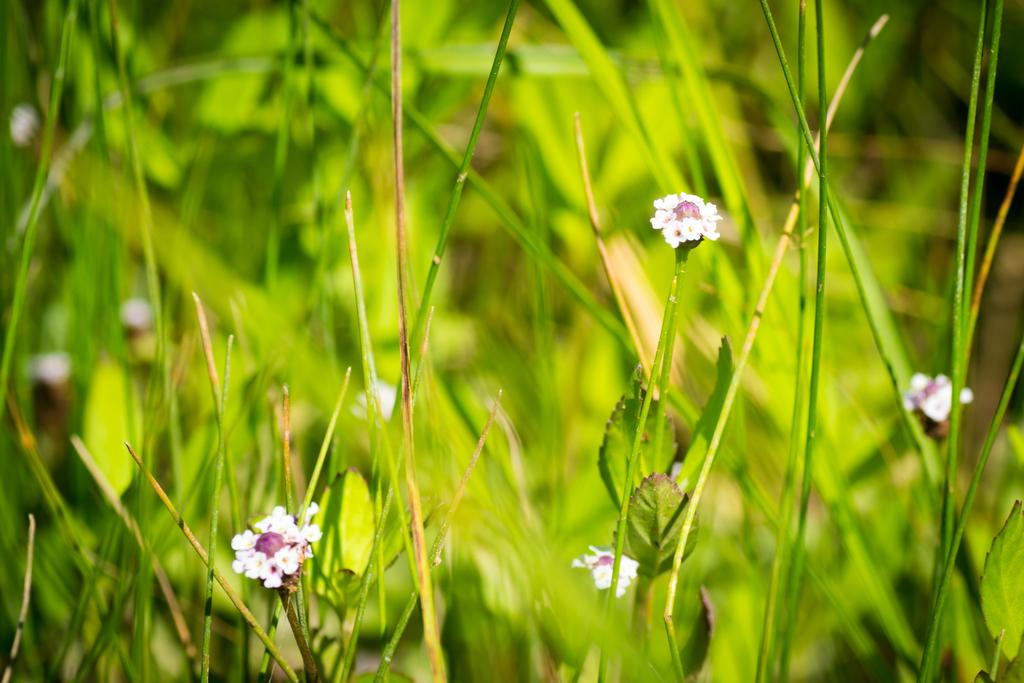What type of living organisms can be seen in the image? There are flowers and plants in the image. Can you describe the plants in the image? The plants in the image are not specified, but they are present alongside the flowers. What type of rat can be seen interacting with the plants in the image? There is no rat present in the image; it only features flowers and plants. How does the hen contribute to the growth of the plants in the image? There is no hen present in the image; it only features flowers and plants. 